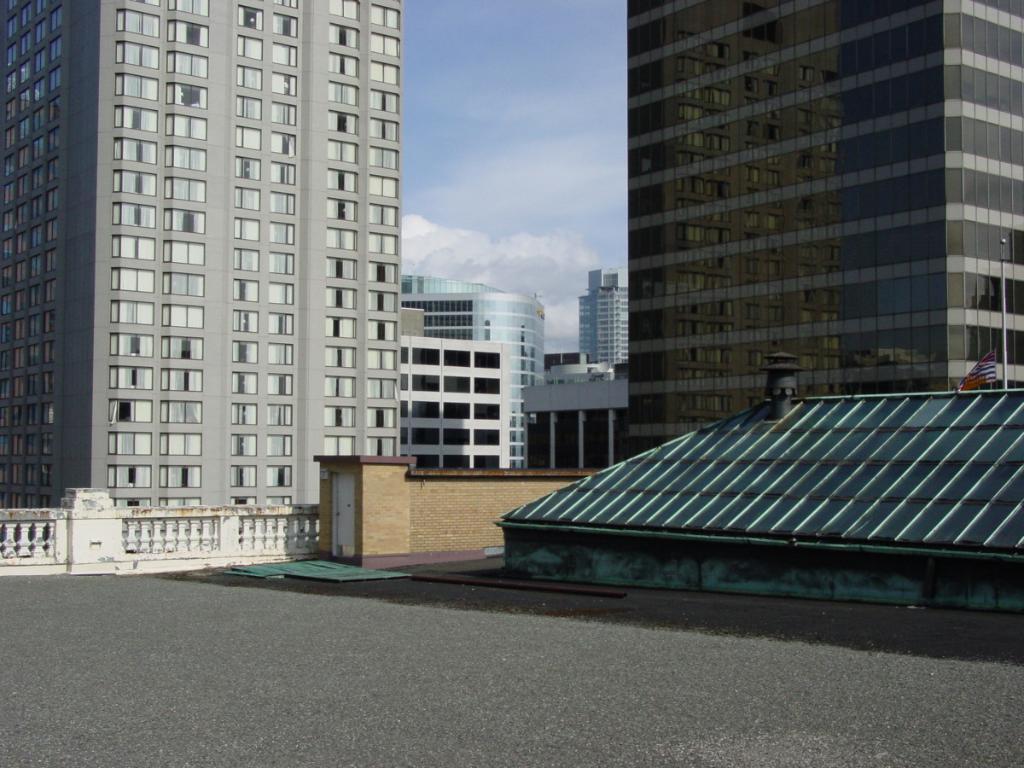Please provide a concise description of this image. In the image we can see there are building and these are the windows of the buildings. Here we can see road, fence and the cloudy sky. Here we can see the pole and the flag. 